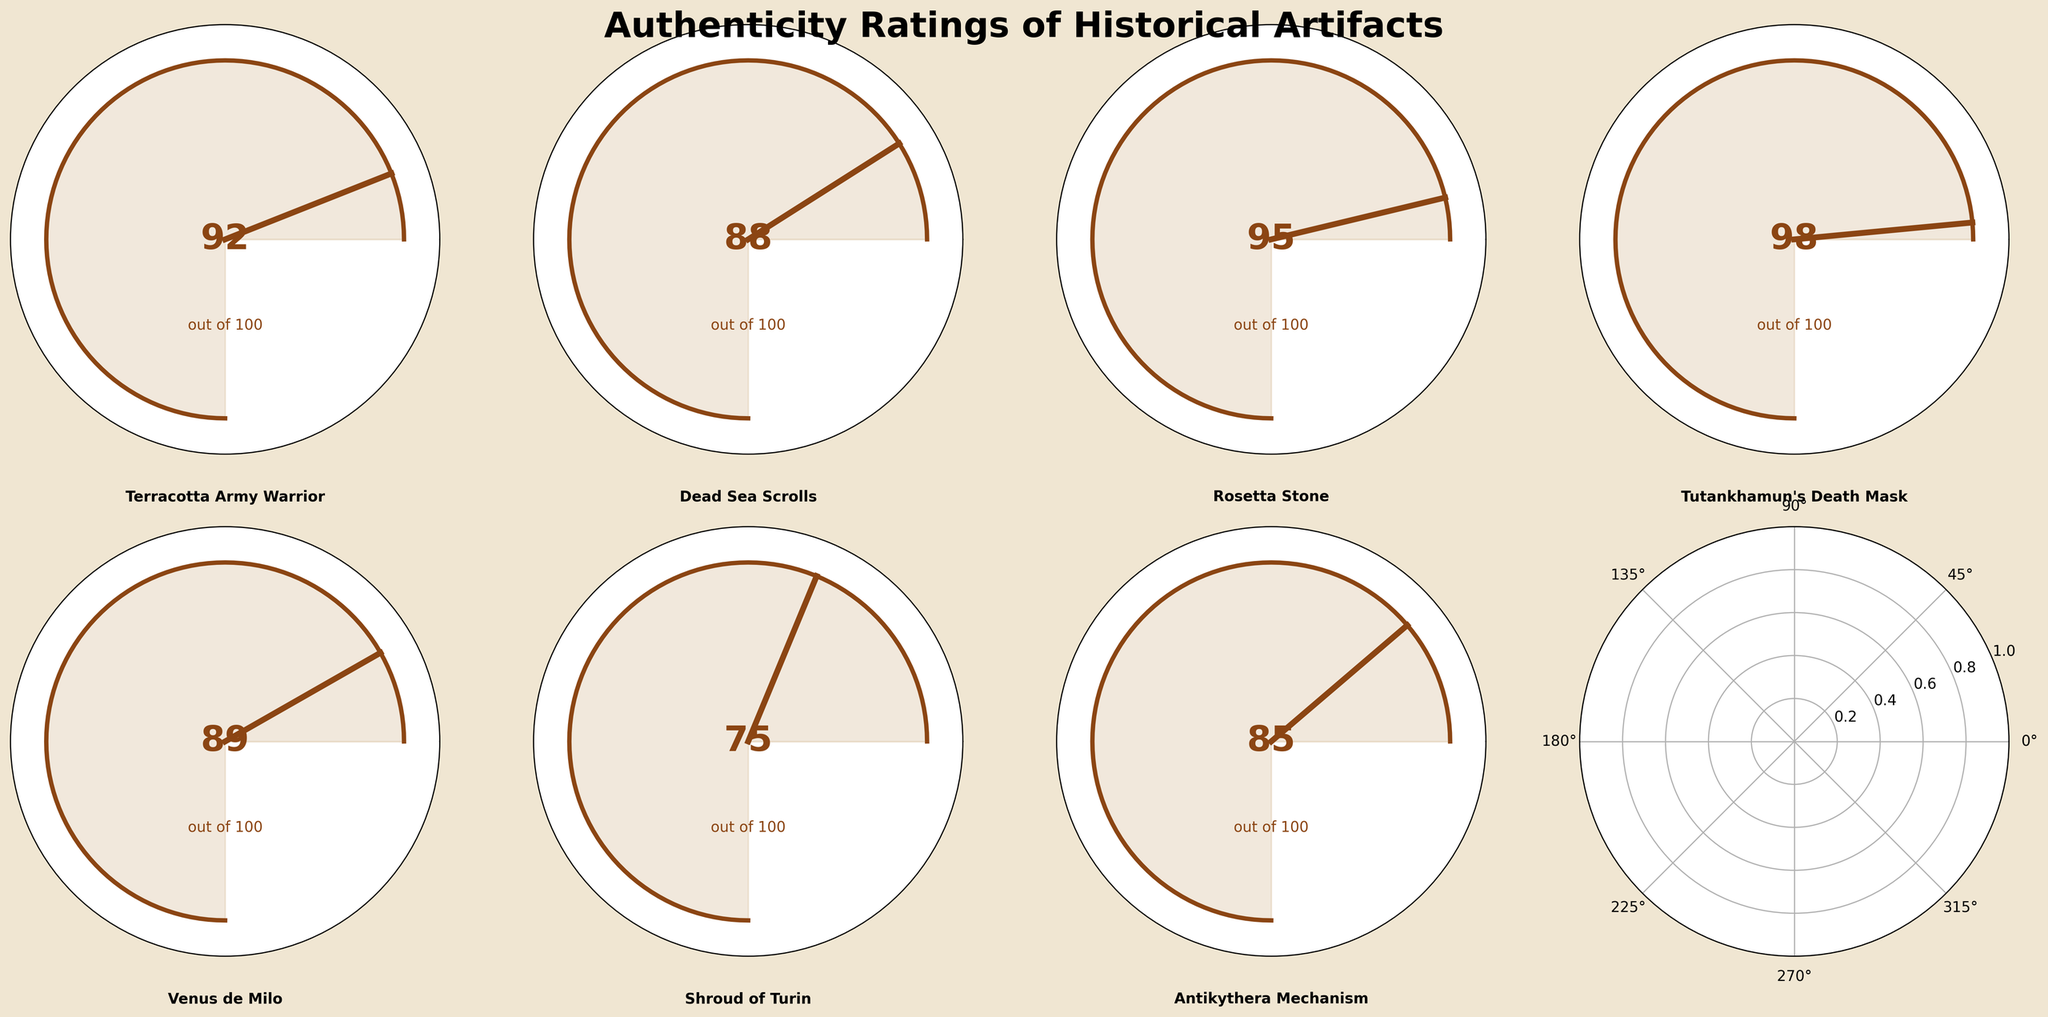What artifact has the highest authenticity rating? The artifact with the highest authenticity rating is the one with the largest number shown in the middle of the gauge chart. Tutankhamun's Death Mask has a rating of 98, which is the highest on the chart.
Answer: Tutankhamun's Death Mask What is the difference in authenticity rating between the Shroud of Turin and the Rosetta Stone? To find the difference, subtract the authenticity rating of the Shroud of Turin (75) from the Rosetta Stone (95). 95 - 75 = 20.
Answer: 20 Which artifacts have an authenticity rating above 90? Artifacts with an authenticity rating above 90 are those where the number in the middle of the gauge chart is greater than 90. They are Terracotta Army Warrior (92), Rosetta Stone (95), and Tutankhamun's Death Mask (98).
Answer: Terracotta Army Warrior, Rosetta Stone, Tutankhamun's Death Mask What is the median authenticity rating of all the artifacts? To find the median, first list all the ratings in ascending order: 75, 85, 88, 89, 92, 95, 98. The middle number in this list is 89, which is the authenticity rating of Venus de Milo.
Answer: 89 How many artifacts have an authenticity rating of less than 85? To count the artifacts with a rating below 85, look at each gauge chart and count those with a number less than 85. The Shroud of Turin (75) and the Antikythera Mechanism (85) are the ones.
Answer: 2 Is there any artifact that has an authenticity rating exactly equal to 85? Check each gauge chart for an authenticity rating of 85. The Antikythera Mechanism has an authenticity rating of exactly 85.
Answer: Yes What is the average authenticity rating of the artifacts displayed? To calculate the average, sum all the authenticity ratings and divide by the number of artifacts. (92 + 88 + 95 + 98 + 89 + 75 + 85) / 7 = 88.857, approximately 88.9.
Answer: 88.9 What is the percentage difference in authenticity ratings between the Terracotta Army Warrior and the Shroud of Turin? First, find the difference in ratings: 92 - 75 = 17. Then calculate the percentage difference relative to the Shroud of Turin rating: (17 / 75) * 100 ≈ 22.67%.
Answer: 22.67% Which artifact has the closest authenticity rating to 90? Look for the artifact with the rating closest to 90. The Terracotta Army Warrior has a rating of 92, which is closest to 90.
Answer: Terracotta Army Warrior Which item has a higher authenticity rating, the Dead Sea Scrolls or the Venus de Milo? Compare the authenticity ratings of the Dead Sea Scrolls (88) and the Venus de Milo (89). Venus de Milo (89) has a higher rating.
Answer: Venus de Milo 